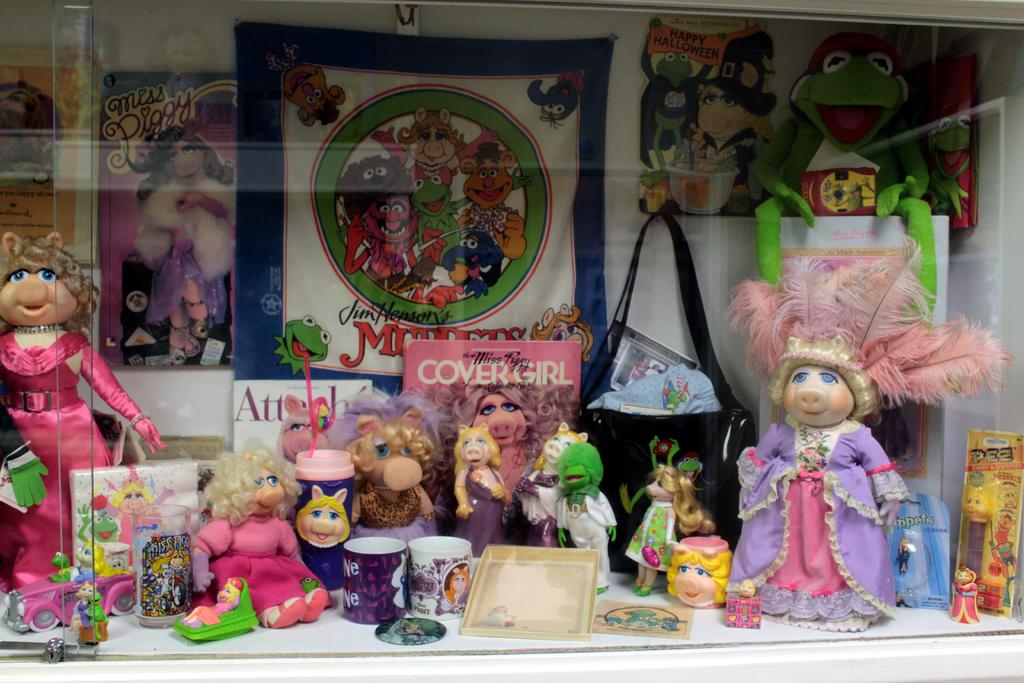<image>
Create a compact narrative representing the image presented. a cover girl magazine has Miss Piggy on the front 